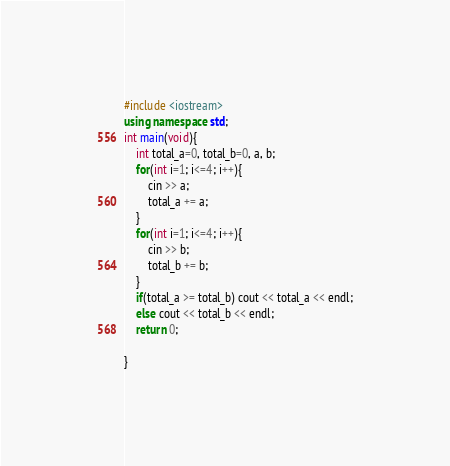Convert code to text. <code><loc_0><loc_0><loc_500><loc_500><_C++_>#include <iostream>
using namespace std;
int main(void){
    int total_a=0, total_b=0, a, b;
    for(int i=1; i<=4; i++){
        cin >> a;
        total_a += a;
    }
    for(int i=1; i<=4; i++){
        cin >> b;
        total_b += b;
    }
    if(total_a >= total_b) cout << total_a << endl;
    else cout << total_b << endl;
    return 0;
    
}

</code> 